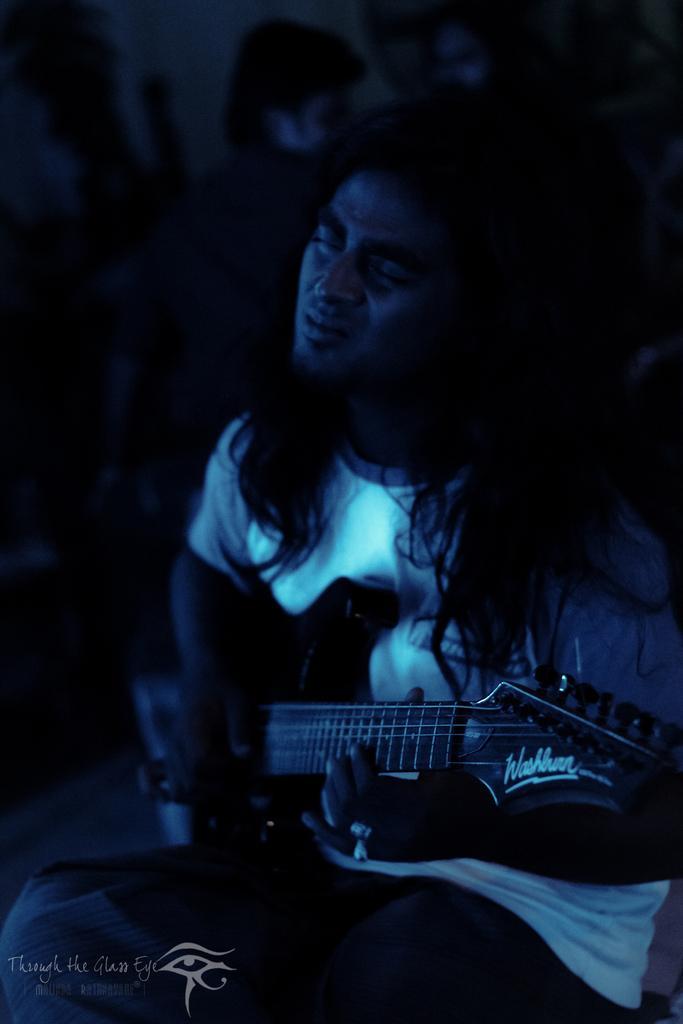Could you give a brief overview of what you see in this image? There is a man in white tee shirt holding a musical instrument and closing his eyes. 